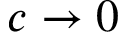Convert formula to latex. <formula><loc_0><loc_0><loc_500><loc_500>c \rightarrow 0</formula> 